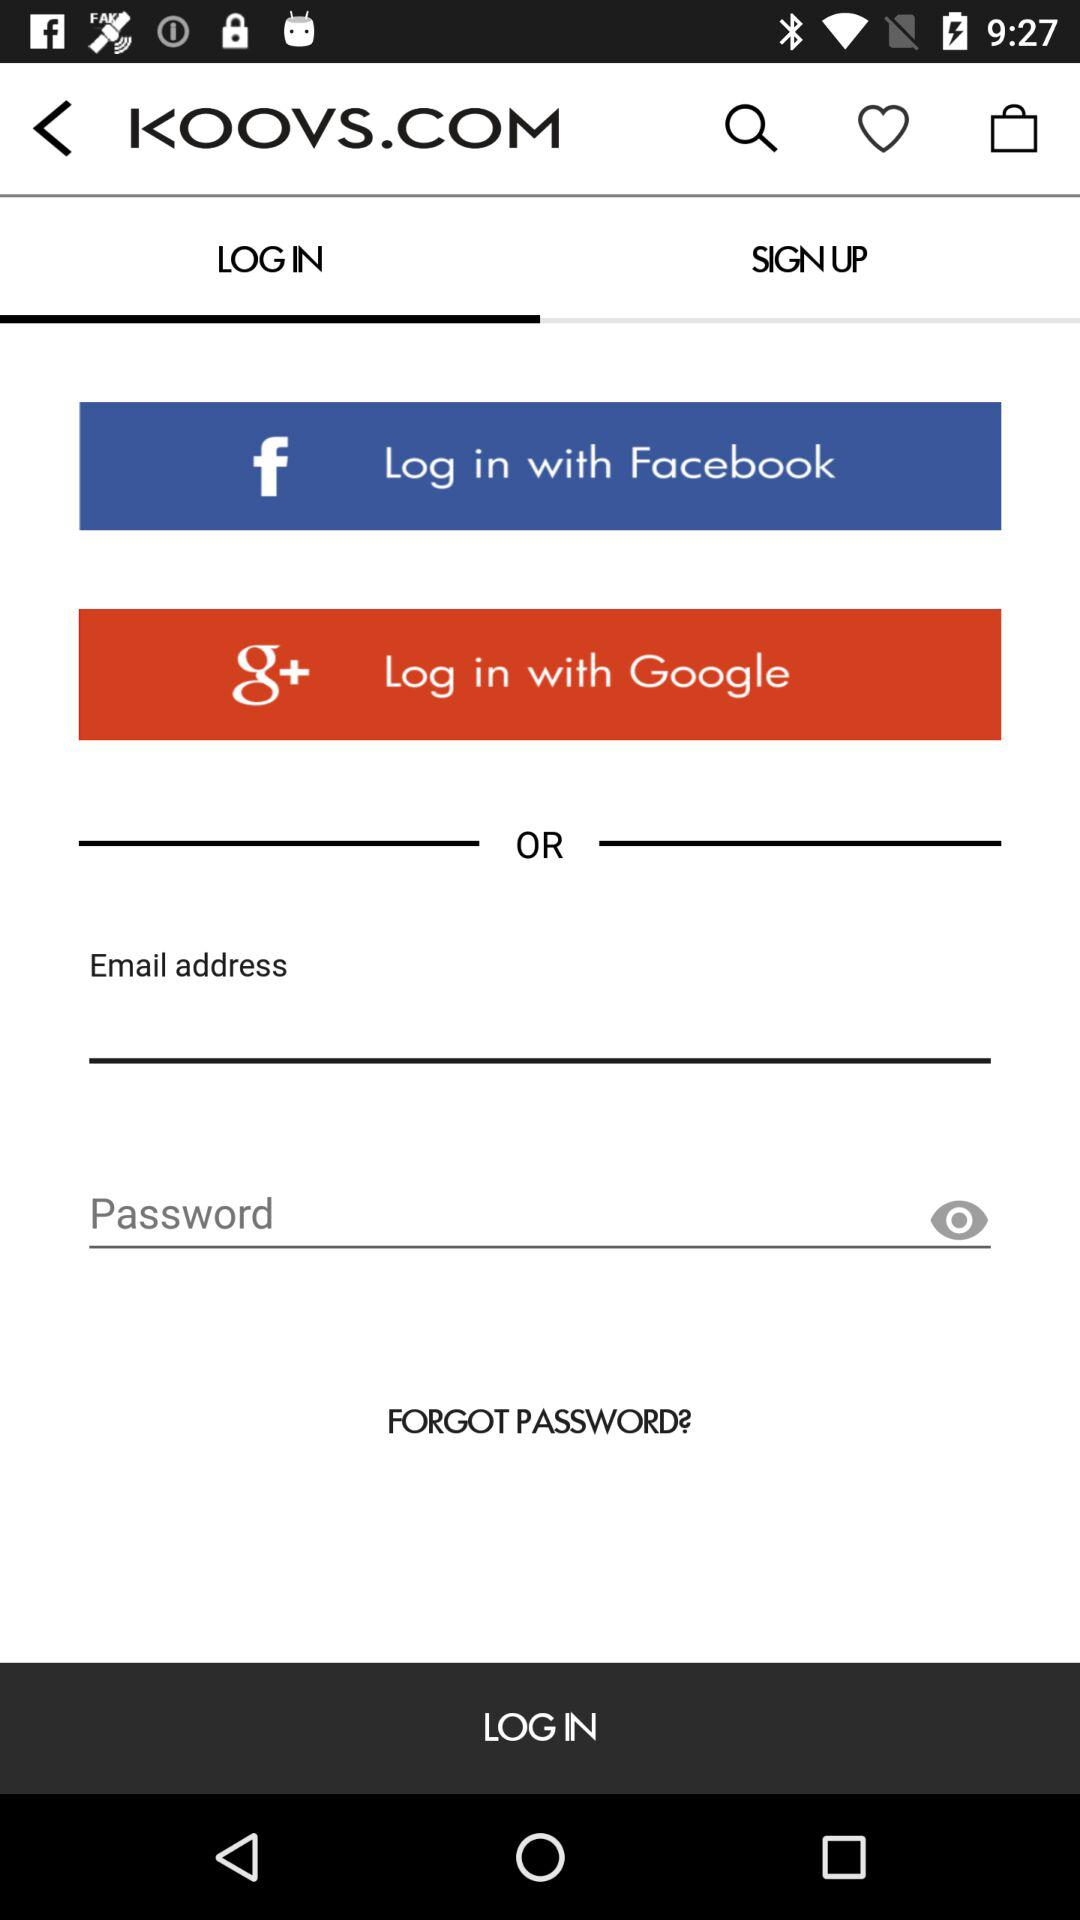What are the login options? The login options are "Facebook", "Google" and "Email". 